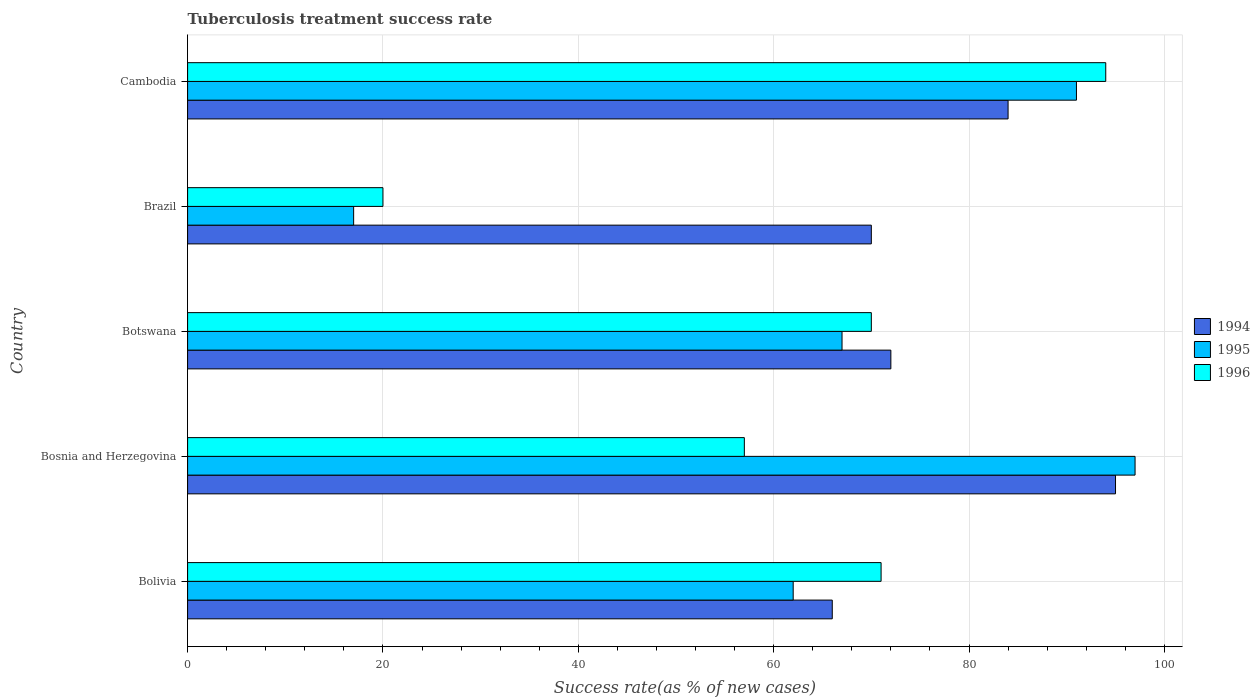How many different coloured bars are there?
Provide a short and direct response. 3. How many bars are there on the 2nd tick from the bottom?
Your answer should be compact. 3. What is the label of the 3rd group of bars from the top?
Give a very brief answer. Botswana. What is the tuberculosis treatment success rate in 1994 in Botswana?
Your response must be concise. 72. Across all countries, what is the maximum tuberculosis treatment success rate in 1995?
Your response must be concise. 97. In which country was the tuberculosis treatment success rate in 1996 maximum?
Give a very brief answer. Cambodia. In which country was the tuberculosis treatment success rate in 1995 minimum?
Provide a short and direct response. Brazil. What is the total tuberculosis treatment success rate in 1995 in the graph?
Provide a short and direct response. 334. What is the difference between the tuberculosis treatment success rate in 1996 in Brazil and that in Cambodia?
Your response must be concise. -74. What is the difference between the tuberculosis treatment success rate in 1996 in Bosnia and Herzegovina and the tuberculosis treatment success rate in 1994 in Cambodia?
Keep it short and to the point. -27. What is the average tuberculosis treatment success rate in 1996 per country?
Ensure brevity in your answer.  62.4. What is the difference between the tuberculosis treatment success rate in 1996 and tuberculosis treatment success rate in 1994 in Bosnia and Herzegovina?
Offer a very short reply. -38. In how many countries, is the tuberculosis treatment success rate in 1996 greater than 24 %?
Your response must be concise. 4. What is the ratio of the tuberculosis treatment success rate in 1996 in Bolivia to that in Brazil?
Provide a short and direct response. 3.55. Is the difference between the tuberculosis treatment success rate in 1996 in Botswana and Brazil greater than the difference between the tuberculosis treatment success rate in 1994 in Botswana and Brazil?
Your answer should be compact. Yes. What is the difference between the highest and the second highest tuberculosis treatment success rate in 1994?
Your answer should be very brief. 11. What is the difference between the highest and the lowest tuberculosis treatment success rate in 1995?
Keep it short and to the point. 80. Is the sum of the tuberculosis treatment success rate in 1996 in Brazil and Cambodia greater than the maximum tuberculosis treatment success rate in 1994 across all countries?
Your answer should be very brief. Yes. How many bars are there?
Your response must be concise. 15. Are all the bars in the graph horizontal?
Offer a very short reply. Yes. What is the difference between two consecutive major ticks on the X-axis?
Ensure brevity in your answer.  20. Are the values on the major ticks of X-axis written in scientific E-notation?
Keep it short and to the point. No. Does the graph contain any zero values?
Your answer should be compact. No. Does the graph contain grids?
Make the answer very short. Yes. Where does the legend appear in the graph?
Your response must be concise. Center right. How many legend labels are there?
Offer a very short reply. 3. How are the legend labels stacked?
Provide a succinct answer. Vertical. What is the title of the graph?
Provide a short and direct response. Tuberculosis treatment success rate. What is the label or title of the X-axis?
Provide a short and direct response. Success rate(as % of new cases). What is the label or title of the Y-axis?
Provide a succinct answer. Country. What is the Success rate(as % of new cases) of 1994 in Bolivia?
Make the answer very short. 66. What is the Success rate(as % of new cases) in 1995 in Bolivia?
Your answer should be compact. 62. What is the Success rate(as % of new cases) of 1996 in Bolivia?
Make the answer very short. 71. What is the Success rate(as % of new cases) in 1994 in Bosnia and Herzegovina?
Give a very brief answer. 95. What is the Success rate(as % of new cases) of 1995 in Bosnia and Herzegovina?
Give a very brief answer. 97. What is the Success rate(as % of new cases) of 1994 in Brazil?
Offer a very short reply. 70. What is the Success rate(as % of new cases) of 1996 in Brazil?
Provide a short and direct response. 20. What is the Success rate(as % of new cases) of 1994 in Cambodia?
Your answer should be compact. 84. What is the Success rate(as % of new cases) in 1995 in Cambodia?
Your response must be concise. 91. What is the Success rate(as % of new cases) in 1996 in Cambodia?
Provide a short and direct response. 94. Across all countries, what is the maximum Success rate(as % of new cases) in 1995?
Your response must be concise. 97. Across all countries, what is the maximum Success rate(as % of new cases) of 1996?
Your answer should be compact. 94. Across all countries, what is the minimum Success rate(as % of new cases) in 1994?
Offer a terse response. 66. Across all countries, what is the minimum Success rate(as % of new cases) of 1996?
Make the answer very short. 20. What is the total Success rate(as % of new cases) of 1994 in the graph?
Your answer should be very brief. 387. What is the total Success rate(as % of new cases) of 1995 in the graph?
Your response must be concise. 334. What is the total Success rate(as % of new cases) in 1996 in the graph?
Your answer should be very brief. 312. What is the difference between the Success rate(as % of new cases) in 1995 in Bolivia and that in Bosnia and Herzegovina?
Ensure brevity in your answer.  -35. What is the difference between the Success rate(as % of new cases) in 1996 in Bolivia and that in Bosnia and Herzegovina?
Ensure brevity in your answer.  14. What is the difference between the Success rate(as % of new cases) of 1994 in Bolivia and that in Botswana?
Your answer should be very brief. -6. What is the difference between the Success rate(as % of new cases) of 1996 in Bolivia and that in Botswana?
Ensure brevity in your answer.  1. What is the difference between the Success rate(as % of new cases) in 1995 in Bolivia and that in Brazil?
Give a very brief answer. 45. What is the difference between the Success rate(as % of new cases) of 1996 in Bolivia and that in Brazil?
Your answer should be compact. 51. What is the difference between the Success rate(as % of new cases) in 1994 in Bosnia and Herzegovina and that in Botswana?
Your answer should be compact. 23. What is the difference between the Success rate(as % of new cases) in 1995 in Bosnia and Herzegovina and that in Botswana?
Offer a very short reply. 30. What is the difference between the Success rate(as % of new cases) in 1994 in Bosnia and Herzegovina and that in Brazil?
Your response must be concise. 25. What is the difference between the Success rate(as % of new cases) of 1995 in Bosnia and Herzegovina and that in Brazil?
Provide a short and direct response. 80. What is the difference between the Success rate(as % of new cases) of 1996 in Bosnia and Herzegovina and that in Brazil?
Provide a short and direct response. 37. What is the difference between the Success rate(as % of new cases) in 1995 in Bosnia and Herzegovina and that in Cambodia?
Make the answer very short. 6. What is the difference between the Success rate(as % of new cases) of 1996 in Bosnia and Herzegovina and that in Cambodia?
Your response must be concise. -37. What is the difference between the Success rate(as % of new cases) in 1996 in Botswana and that in Brazil?
Keep it short and to the point. 50. What is the difference between the Success rate(as % of new cases) in 1994 in Botswana and that in Cambodia?
Give a very brief answer. -12. What is the difference between the Success rate(as % of new cases) in 1995 in Botswana and that in Cambodia?
Your response must be concise. -24. What is the difference between the Success rate(as % of new cases) in 1996 in Botswana and that in Cambodia?
Your answer should be very brief. -24. What is the difference between the Success rate(as % of new cases) in 1994 in Brazil and that in Cambodia?
Keep it short and to the point. -14. What is the difference between the Success rate(as % of new cases) in 1995 in Brazil and that in Cambodia?
Offer a terse response. -74. What is the difference between the Success rate(as % of new cases) in 1996 in Brazil and that in Cambodia?
Keep it short and to the point. -74. What is the difference between the Success rate(as % of new cases) in 1994 in Bolivia and the Success rate(as % of new cases) in 1995 in Bosnia and Herzegovina?
Keep it short and to the point. -31. What is the difference between the Success rate(as % of new cases) of 1994 in Bolivia and the Success rate(as % of new cases) of 1996 in Bosnia and Herzegovina?
Offer a very short reply. 9. What is the difference between the Success rate(as % of new cases) of 1995 in Bolivia and the Success rate(as % of new cases) of 1996 in Bosnia and Herzegovina?
Your answer should be very brief. 5. What is the difference between the Success rate(as % of new cases) in 1994 in Bolivia and the Success rate(as % of new cases) in 1996 in Brazil?
Your answer should be compact. 46. What is the difference between the Success rate(as % of new cases) in 1995 in Bolivia and the Success rate(as % of new cases) in 1996 in Cambodia?
Your response must be concise. -32. What is the difference between the Success rate(as % of new cases) in 1994 in Bosnia and Herzegovina and the Success rate(as % of new cases) in 1996 in Botswana?
Make the answer very short. 25. What is the difference between the Success rate(as % of new cases) in 1995 in Bosnia and Herzegovina and the Success rate(as % of new cases) in 1996 in Botswana?
Provide a succinct answer. 27. What is the difference between the Success rate(as % of new cases) in 1994 in Bosnia and Herzegovina and the Success rate(as % of new cases) in 1995 in Cambodia?
Your answer should be very brief. 4. What is the difference between the Success rate(as % of new cases) of 1994 in Botswana and the Success rate(as % of new cases) of 1995 in Cambodia?
Offer a terse response. -19. What is the difference between the Success rate(as % of new cases) of 1994 in Brazil and the Success rate(as % of new cases) of 1995 in Cambodia?
Ensure brevity in your answer.  -21. What is the difference between the Success rate(as % of new cases) in 1994 in Brazil and the Success rate(as % of new cases) in 1996 in Cambodia?
Offer a terse response. -24. What is the difference between the Success rate(as % of new cases) in 1995 in Brazil and the Success rate(as % of new cases) in 1996 in Cambodia?
Offer a very short reply. -77. What is the average Success rate(as % of new cases) in 1994 per country?
Your answer should be compact. 77.4. What is the average Success rate(as % of new cases) in 1995 per country?
Keep it short and to the point. 66.8. What is the average Success rate(as % of new cases) of 1996 per country?
Your answer should be compact. 62.4. What is the difference between the Success rate(as % of new cases) of 1995 and Success rate(as % of new cases) of 1996 in Bolivia?
Give a very brief answer. -9. What is the difference between the Success rate(as % of new cases) of 1994 and Success rate(as % of new cases) of 1995 in Botswana?
Your answer should be very brief. 5. What is the difference between the Success rate(as % of new cases) in 1994 and Success rate(as % of new cases) in 1996 in Botswana?
Provide a succinct answer. 2. What is the difference between the Success rate(as % of new cases) in 1995 and Success rate(as % of new cases) in 1996 in Brazil?
Offer a terse response. -3. What is the difference between the Success rate(as % of new cases) in 1994 and Success rate(as % of new cases) in 1996 in Cambodia?
Provide a short and direct response. -10. What is the difference between the Success rate(as % of new cases) in 1995 and Success rate(as % of new cases) in 1996 in Cambodia?
Your response must be concise. -3. What is the ratio of the Success rate(as % of new cases) of 1994 in Bolivia to that in Bosnia and Herzegovina?
Your response must be concise. 0.69. What is the ratio of the Success rate(as % of new cases) in 1995 in Bolivia to that in Bosnia and Herzegovina?
Offer a terse response. 0.64. What is the ratio of the Success rate(as % of new cases) of 1996 in Bolivia to that in Bosnia and Herzegovina?
Offer a terse response. 1.25. What is the ratio of the Success rate(as % of new cases) of 1995 in Bolivia to that in Botswana?
Your response must be concise. 0.93. What is the ratio of the Success rate(as % of new cases) in 1996 in Bolivia to that in Botswana?
Provide a short and direct response. 1.01. What is the ratio of the Success rate(as % of new cases) in 1994 in Bolivia to that in Brazil?
Provide a succinct answer. 0.94. What is the ratio of the Success rate(as % of new cases) of 1995 in Bolivia to that in Brazil?
Ensure brevity in your answer.  3.65. What is the ratio of the Success rate(as % of new cases) in 1996 in Bolivia to that in Brazil?
Ensure brevity in your answer.  3.55. What is the ratio of the Success rate(as % of new cases) of 1994 in Bolivia to that in Cambodia?
Offer a terse response. 0.79. What is the ratio of the Success rate(as % of new cases) of 1995 in Bolivia to that in Cambodia?
Your response must be concise. 0.68. What is the ratio of the Success rate(as % of new cases) in 1996 in Bolivia to that in Cambodia?
Ensure brevity in your answer.  0.76. What is the ratio of the Success rate(as % of new cases) of 1994 in Bosnia and Herzegovina to that in Botswana?
Provide a short and direct response. 1.32. What is the ratio of the Success rate(as % of new cases) of 1995 in Bosnia and Herzegovina to that in Botswana?
Ensure brevity in your answer.  1.45. What is the ratio of the Success rate(as % of new cases) of 1996 in Bosnia and Herzegovina to that in Botswana?
Your response must be concise. 0.81. What is the ratio of the Success rate(as % of new cases) in 1994 in Bosnia and Herzegovina to that in Brazil?
Ensure brevity in your answer.  1.36. What is the ratio of the Success rate(as % of new cases) in 1995 in Bosnia and Herzegovina to that in Brazil?
Your answer should be very brief. 5.71. What is the ratio of the Success rate(as % of new cases) of 1996 in Bosnia and Herzegovina to that in Brazil?
Make the answer very short. 2.85. What is the ratio of the Success rate(as % of new cases) of 1994 in Bosnia and Herzegovina to that in Cambodia?
Keep it short and to the point. 1.13. What is the ratio of the Success rate(as % of new cases) of 1995 in Bosnia and Herzegovina to that in Cambodia?
Your response must be concise. 1.07. What is the ratio of the Success rate(as % of new cases) of 1996 in Bosnia and Herzegovina to that in Cambodia?
Offer a terse response. 0.61. What is the ratio of the Success rate(as % of new cases) of 1994 in Botswana to that in Brazil?
Your response must be concise. 1.03. What is the ratio of the Success rate(as % of new cases) in 1995 in Botswana to that in Brazil?
Offer a terse response. 3.94. What is the ratio of the Success rate(as % of new cases) of 1994 in Botswana to that in Cambodia?
Your answer should be compact. 0.86. What is the ratio of the Success rate(as % of new cases) of 1995 in Botswana to that in Cambodia?
Make the answer very short. 0.74. What is the ratio of the Success rate(as % of new cases) in 1996 in Botswana to that in Cambodia?
Keep it short and to the point. 0.74. What is the ratio of the Success rate(as % of new cases) of 1995 in Brazil to that in Cambodia?
Keep it short and to the point. 0.19. What is the ratio of the Success rate(as % of new cases) in 1996 in Brazil to that in Cambodia?
Provide a succinct answer. 0.21. What is the difference between the highest and the second highest Success rate(as % of new cases) in 1995?
Provide a short and direct response. 6. What is the difference between the highest and the lowest Success rate(as % of new cases) of 1994?
Offer a terse response. 29. What is the difference between the highest and the lowest Success rate(as % of new cases) in 1995?
Provide a short and direct response. 80. 